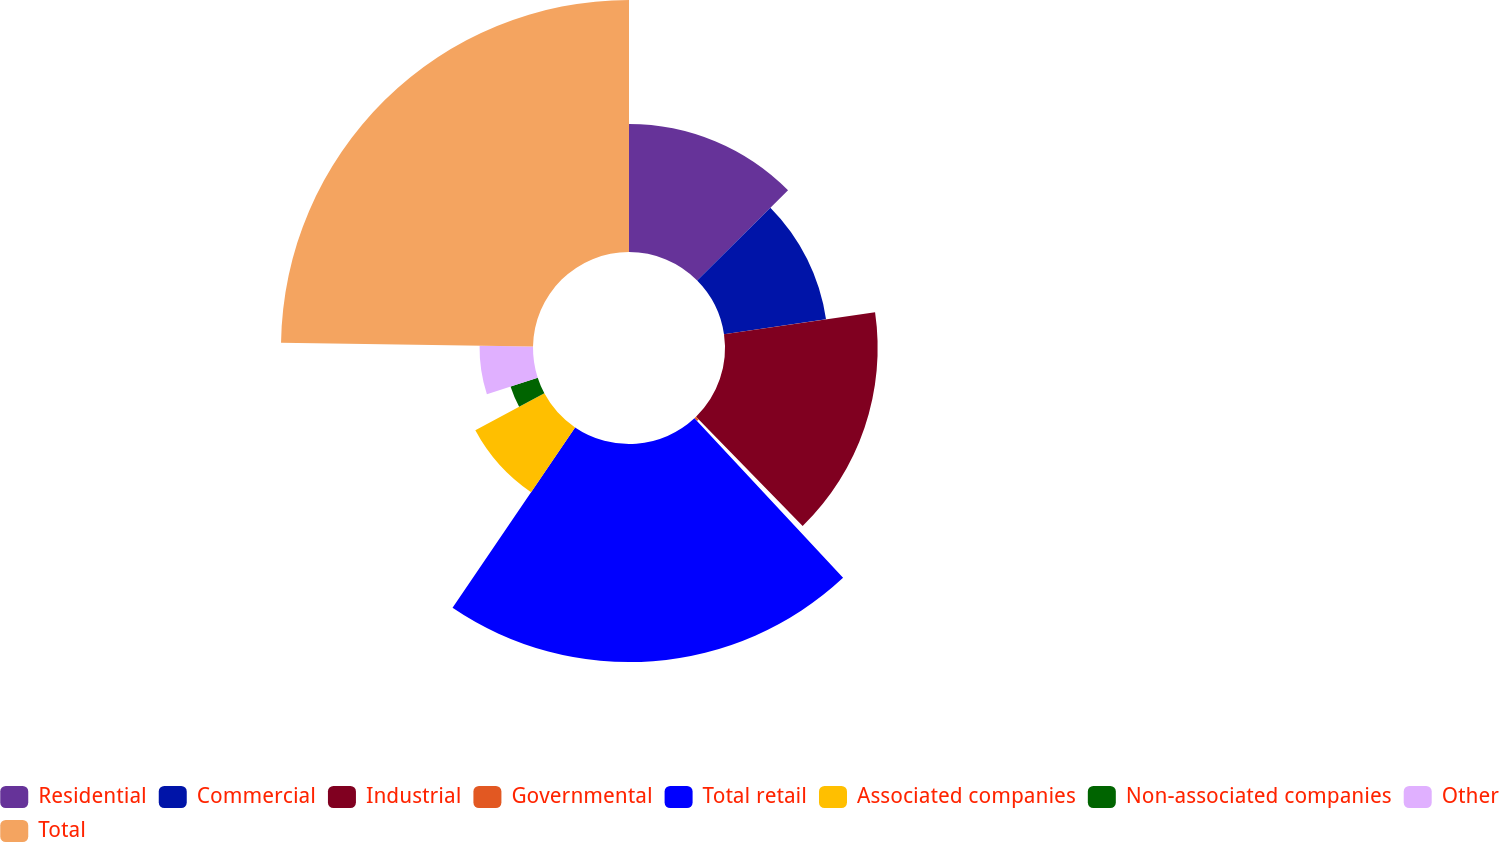<chart> <loc_0><loc_0><loc_500><loc_500><pie_chart><fcel>Residential<fcel>Commercial<fcel>Industrial<fcel>Governmental<fcel>Total retail<fcel>Associated companies<fcel>Non-associated companies<fcel>Other<fcel>Total<nl><fcel>12.57%<fcel>10.13%<fcel>15.0%<fcel>0.37%<fcel>21.43%<fcel>7.69%<fcel>2.81%<fcel>5.25%<fcel>24.76%<nl></chart> 